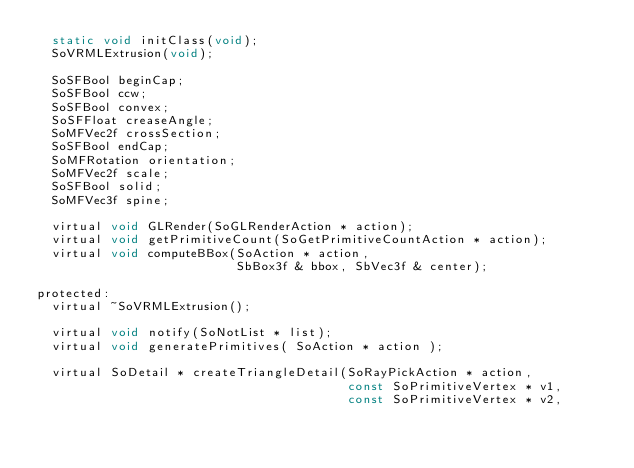Convert code to text. <code><loc_0><loc_0><loc_500><loc_500><_C_>  static void initClass(void);
  SoVRMLExtrusion(void);

  SoSFBool beginCap;
  SoSFBool ccw;
  SoSFBool convex;
  SoSFFloat creaseAngle;
  SoMFVec2f crossSection;
  SoSFBool endCap;
  SoMFRotation orientation;
  SoMFVec2f scale;
  SoSFBool solid;
  SoMFVec3f spine;

  virtual void GLRender(SoGLRenderAction * action);
  virtual void getPrimitiveCount(SoGetPrimitiveCountAction * action);
  virtual void computeBBox(SoAction * action,
                           SbBox3f & bbox, SbVec3f & center);

protected:
  virtual ~SoVRMLExtrusion();

  virtual void notify(SoNotList * list);
  virtual void generatePrimitives( SoAction * action );

  virtual SoDetail * createTriangleDetail(SoRayPickAction * action,
                                          const SoPrimitiveVertex * v1,
                                          const SoPrimitiveVertex * v2,</code> 